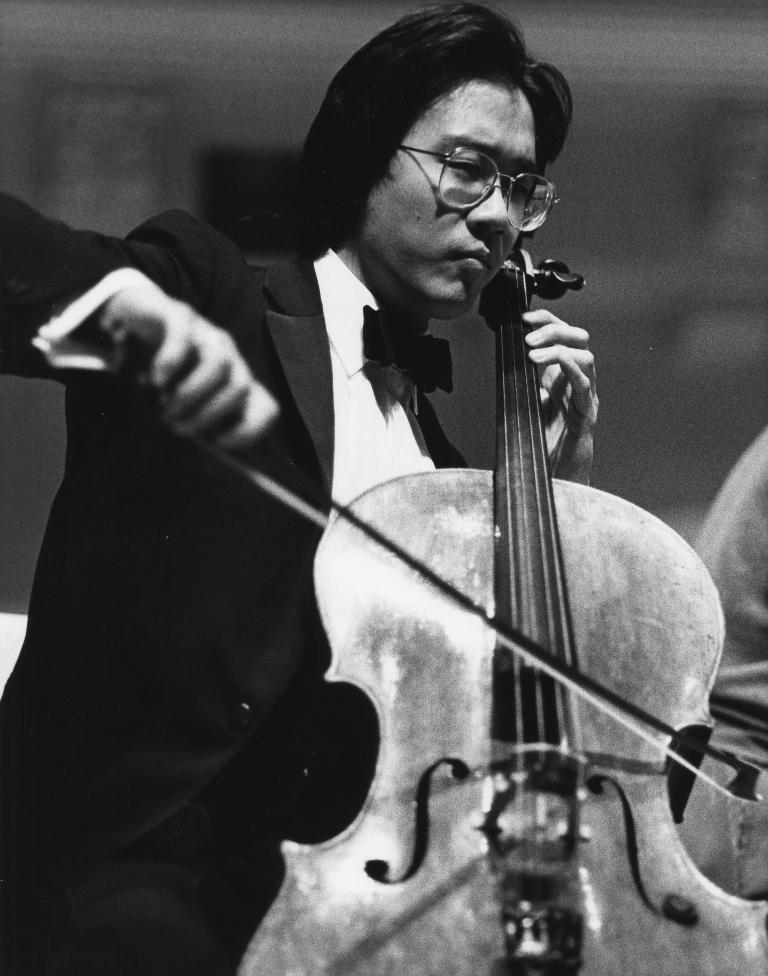What is the main subject of the image? The main subject of the image is a man. What is the man doing in the image? The man is playing a musical instrument in the image. What type of waves can be seen crashing on the shore in the image? There are no waves or shore visible in the image; it features a man playing a musical instrument. What is the man eating for dinner in the image? There is no dinner or food present in the image; the man is playing a musical instrument. 